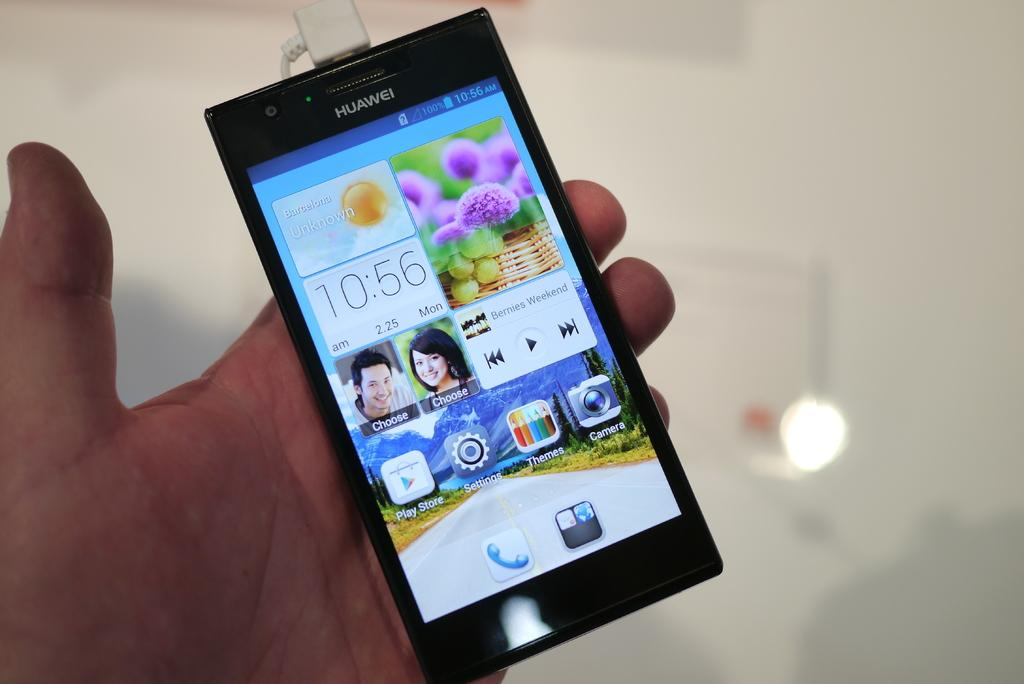<image>
Share a concise interpretation of the image provided. A Huawei phone displays a clock and icons for Themes, Camera and Play Store on its screen. 